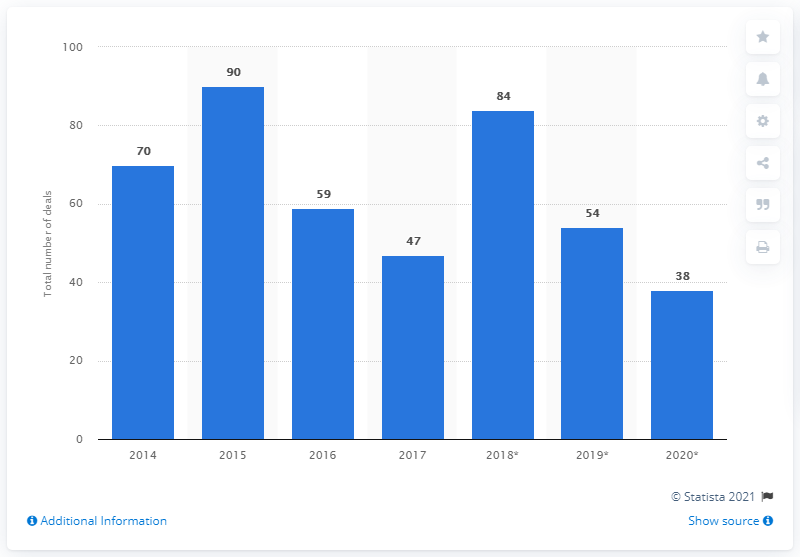List a handful of essential elements in this visual. The difference in average between the historical data and the forecasted data is 7.83. The start year of this data is represented as 2014. By 2020, it was projected that domestic deals would reach a total of 38. There were 47 domestic mergers and acquisitions deals in Belgium in 2017. 